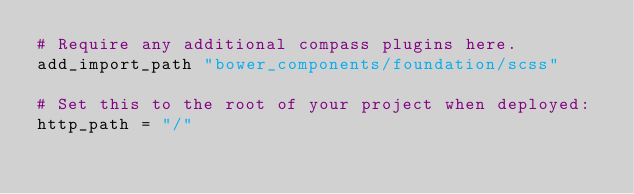Convert code to text. <code><loc_0><loc_0><loc_500><loc_500><_Ruby_># Require any additional compass plugins here.
add_import_path "bower_components/foundation/scss"

# Set this to the root of your project when deployed:
http_path = "/"</code> 